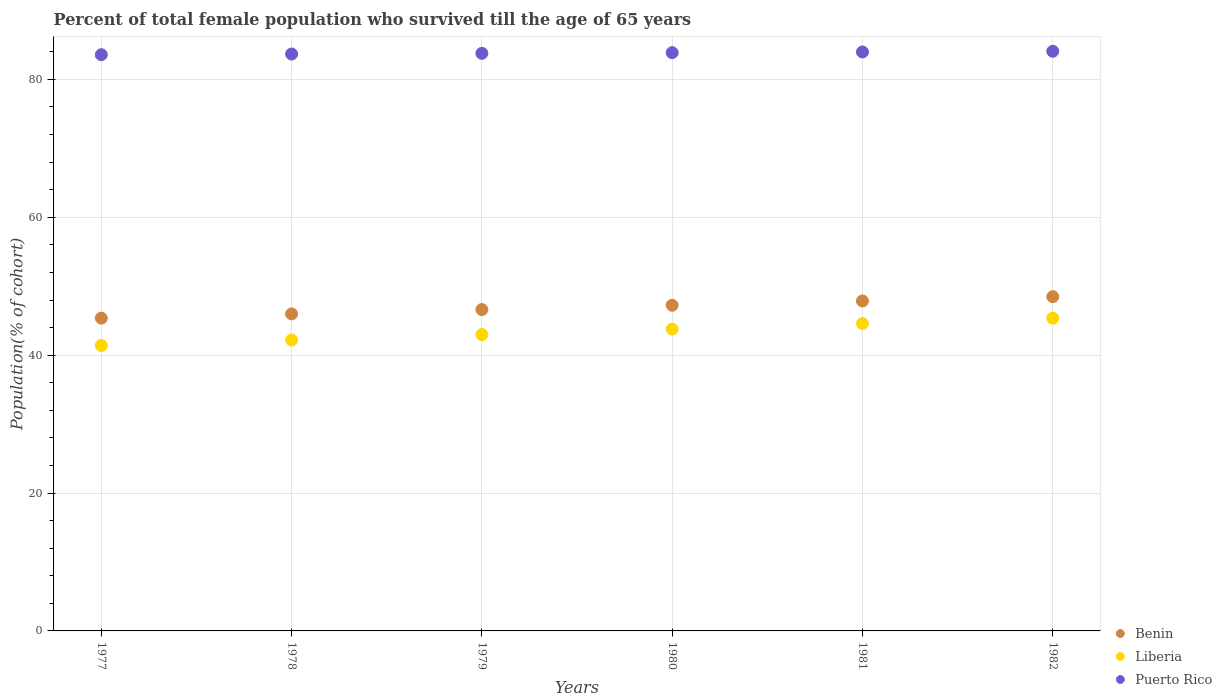Is the number of dotlines equal to the number of legend labels?
Give a very brief answer. Yes. What is the percentage of total female population who survived till the age of 65 years in Liberia in 1978?
Your answer should be very brief. 42.19. Across all years, what is the maximum percentage of total female population who survived till the age of 65 years in Benin?
Keep it short and to the point. 48.49. Across all years, what is the minimum percentage of total female population who survived till the age of 65 years in Benin?
Ensure brevity in your answer.  45.37. In which year was the percentage of total female population who survived till the age of 65 years in Puerto Rico maximum?
Offer a very short reply. 1982. In which year was the percentage of total female population who survived till the age of 65 years in Puerto Rico minimum?
Ensure brevity in your answer.  1977. What is the total percentage of total female population who survived till the age of 65 years in Liberia in the graph?
Offer a terse response. 260.31. What is the difference between the percentage of total female population who survived till the age of 65 years in Puerto Rico in 1979 and that in 1982?
Keep it short and to the point. -0.3. What is the difference between the percentage of total female population who survived till the age of 65 years in Liberia in 1978 and the percentage of total female population who survived till the age of 65 years in Puerto Rico in 1982?
Offer a very short reply. -41.88. What is the average percentage of total female population who survived till the age of 65 years in Liberia per year?
Your response must be concise. 43.38. In the year 1978, what is the difference between the percentage of total female population who survived till the age of 65 years in Benin and percentage of total female population who survived till the age of 65 years in Liberia?
Give a very brief answer. 3.8. In how many years, is the percentage of total female population who survived till the age of 65 years in Liberia greater than 80 %?
Provide a short and direct response. 0. What is the ratio of the percentage of total female population who survived till the age of 65 years in Puerto Rico in 1977 to that in 1979?
Keep it short and to the point. 1. Is the difference between the percentage of total female population who survived till the age of 65 years in Benin in 1977 and 1978 greater than the difference between the percentage of total female population who survived till the age of 65 years in Liberia in 1977 and 1978?
Offer a terse response. Yes. What is the difference between the highest and the second highest percentage of total female population who survived till the age of 65 years in Puerto Rico?
Provide a short and direct response. 0.1. What is the difference between the highest and the lowest percentage of total female population who survived till the age of 65 years in Puerto Rico?
Your answer should be compact. 0.5. In how many years, is the percentage of total female population who survived till the age of 65 years in Liberia greater than the average percentage of total female population who survived till the age of 65 years in Liberia taken over all years?
Keep it short and to the point. 3. Is the sum of the percentage of total female population who survived till the age of 65 years in Benin in 1979 and 1980 greater than the maximum percentage of total female population who survived till the age of 65 years in Puerto Rico across all years?
Your answer should be compact. Yes. Is it the case that in every year, the sum of the percentage of total female population who survived till the age of 65 years in Liberia and percentage of total female population who survived till the age of 65 years in Puerto Rico  is greater than the percentage of total female population who survived till the age of 65 years in Benin?
Ensure brevity in your answer.  Yes. Does the percentage of total female population who survived till the age of 65 years in Puerto Rico monotonically increase over the years?
Ensure brevity in your answer.  Yes. Are the values on the major ticks of Y-axis written in scientific E-notation?
Offer a very short reply. No. Does the graph contain grids?
Provide a short and direct response. Yes. Where does the legend appear in the graph?
Offer a terse response. Bottom right. How many legend labels are there?
Your answer should be very brief. 3. What is the title of the graph?
Ensure brevity in your answer.  Percent of total female population who survived till the age of 65 years. Does "European Union" appear as one of the legend labels in the graph?
Provide a succinct answer. No. What is the label or title of the X-axis?
Ensure brevity in your answer.  Years. What is the label or title of the Y-axis?
Make the answer very short. Population(% of cohort). What is the Population(% of cohort) in Benin in 1977?
Provide a short and direct response. 45.37. What is the Population(% of cohort) in Liberia in 1977?
Keep it short and to the point. 41.4. What is the Population(% of cohort) in Puerto Rico in 1977?
Make the answer very short. 83.58. What is the Population(% of cohort) in Benin in 1978?
Offer a very short reply. 45.99. What is the Population(% of cohort) in Liberia in 1978?
Your answer should be compact. 42.19. What is the Population(% of cohort) of Puerto Rico in 1978?
Ensure brevity in your answer.  83.68. What is the Population(% of cohort) of Benin in 1979?
Your answer should be very brief. 46.61. What is the Population(% of cohort) in Liberia in 1979?
Give a very brief answer. 42.99. What is the Population(% of cohort) of Puerto Rico in 1979?
Keep it short and to the point. 83.78. What is the Population(% of cohort) in Benin in 1980?
Your answer should be very brief. 47.24. What is the Population(% of cohort) of Liberia in 1980?
Your answer should be very brief. 43.78. What is the Population(% of cohort) of Puerto Rico in 1980?
Offer a terse response. 83.88. What is the Population(% of cohort) in Benin in 1981?
Your response must be concise. 47.86. What is the Population(% of cohort) of Liberia in 1981?
Your answer should be compact. 44.58. What is the Population(% of cohort) in Puerto Rico in 1981?
Keep it short and to the point. 83.98. What is the Population(% of cohort) in Benin in 1982?
Provide a short and direct response. 48.49. What is the Population(% of cohort) in Liberia in 1982?
Offer a terse response. 45.37. What is the Population(% of cohort) of Puerto Rico in 1982?
Give a very brief answer. 84.08. Across all years, what is the maximum Population(% of cohort) of Benin?
Provide a short and direct response. 48.49. Across all years, what is the maximum Population(% of cohort) of Liberia?
Provide a succinct answer. 45.37. Across all years, what is the maximum Population(% of cohort) in Puerto Rico?
Keep it short and to the point. 84.08. Across all years, what is the minimum Population(% of cohort) of Benin?
Offer a terse response. 45.37. Across all years, what is the minimum Population(% of cohort) in Liberia?
Provide a succinct answer. 41.4. Across all years, what is the minimum Population(% of cohort) of Puerto Rico?
Your answer should be very brief. 83.58. What is the total Population(% of cohort) of Benin in the graph?
Offer a very short reply. 281.56. What is the total Population(% of cohort) in Liberia in the graph?
Keep it short and to the point. 260.31. What is the total Population(% of cohort) in Puerto Rico in the graph?
Offer a terse response. 502.97. What is the difference between the Population(% of cohort) in Benin in 1977 and that in 1978?
Provide a short and direct response. -0.62. What is the difference between the Population(% of cohort) of Liberia in 1977 and that in 1978?
Offer a terse response. -0.79. What is the difference between the Population(% of cohort) of Puerto Rico in 1977 and that in 1978?
Offer a terse response. -0.1. What is the difference between the Population(% of cohort) of Benin in 1977 and that in 1979?
Offer a terse response. -1.25. What is the difference between the Population(% of cohort) in Liberia in 1977 and that in 1979?
Ensure brevity in your answer.  -1.59. What is the difference between the Population(% of cohort) of Puerto Rico in 1977 and that in 1979?
Your answer should be compact. -0.2. What is the difference between the Population(% of cohort) in Benin in 1977 and that in 1980?
Your response must be concise. -1.87. What is the difference between the Population(% of cohort) of Liberia in 1977 and that in 1980?
Your response must be concise. -2.38. What is the difference between the Population(% of cohort) in Puerto Rico in 1977 and that in 1980?
Ensure brevity in your answer.  -0.3. What is the difference between the Population(% of cohort) in Benin in 1977 and that in 1981?
Your response must be concise. -2.5. What is the difference between the Population(% of cohort) of Liberia in 1977 and that in 1981?
Make the answer very short. -3.18. What is the difference between the Population(% of cohort) of Puerto Rico in 1977 and that in 1981?
Provide a succinct answer. -0.4. What is the difference between the Population(% of cohort) in Benin in 1977 and that in 1982?
Provide a short and direct response. -3.12. What is the difference between the Population(% of cohort) of Liberia in 1977 and that in 1982?
Offer a very short reply. -3.97. What is the difference between the Population(% of cohort) of Puerto Rico in 1977 and that in 1982?
Your response must be concise. -0.5. What is the difference between the Population(% of cohort) in Benin in 1978 and that in 1979?
Offer a very short reply. -0.62. What is the difference between the Population(% of cohort) of Liberia in 1978 and that in 1979?
Offer a terse response. -0.79. What is the difference between the Population(% of cohort) in Puerto Rico in 1978 and that in 1979?
Provide a short and direct response. -0.1. What is the difference between the Population(% of cohort) of Benin in 1978 and that in 1980?
Ensure brevity in your answer.  -1.25. What is the difference between the Population(% of cohort) of Liberia in 1978 and that in 1980?
Give a very brief answer. -1.59. What is the difference between the Population(% of cohort) of Puerto Rico in 1978 and that in 1980?
Your answer should be compact. -0.2. What is the difference between the Population(% of cohort) of Benin in 1978 and that in 1981?
Your answer should be very brief. -1.87. What is the difference between the Population(% of cohort) in Liberia in 1978 and that in 1981?
Ensure brevity in your answer.  -2.38. What is the difference between the Population(% of cohort) in Puerto Rico in 1978 and that in 1981?
Provide a short and direct response. -0.3. What is the difference between the Population(% of cohort) in Benin in 1978 and that in 1982?
Keep it short and to the point. -2.5. What is the difference between the Population(% of cohort) in Liberia in 1978 and that in 1982?
Provide a short and direct response. -3.18. What is the difference between the Population(% of cohort) in Puerto Rico in 1978 and that in 1982?
Make the answer very short. -0.4. What is the difference between the Population(% of cohort) in Benin in 1979 and that in 1980?
Offer a terse response. -0.62. What is the difference between the Population(% of cohort) of Liberia in 1979 and that in 1980?
Your answer should be very brief. -0.79. What is the difference between the Population(% of cohort) in Puerto Rico in 1979 and that in 1980?
Ensure brevity in your answer.  -0.1. What is the difference between the Population(% of cohort) in Benin in 1979 and that in 1981?
Provide a short and direct response. -1.25. What is the difference between the Population(% of cohort) in Liberia in 1979 and that in 1981?
Your answer should be compact. -1.59. What is the difference between the Population(% of cohort) of Puerto Rico in 1979 and that in 1981?
Provide a short and direct response. -0.2. What is the difference between the Population(% of cohort) of Benin in 1979 and that in 1982?
Provide a short and direct response. -1.87. What is the difference between the Population(% of cohort) of Liberia in 1979 and that in 1982?
Provide a succinct answer. -2.38. What is the difference between the Population(% of cohort) in Puerto Rico in 1979 and that in 1982?
Ensure brevity in your answer.  -0.3. What is the difference between the Population(% of cohort) of Benin in 1980 and that in 1981?
Your answer should be very brief. -0.62. What is the difference between the Population(% of cohort) in Liberia in 1980 and that in 1981?
Your answer should be very brief. -0.79. What is the difference between the Population(% of cohort) in Puerto Rico in 1980 and that in 1981?
Offer a very short reply. -0.1. What is the difference between the Population(% of cohort) in Benin in 1980 and that in 1982?
Provide a succinct answer. -1.25. What is the difference between the Population(% of cohort) of Liberia in 1980 and that in 1982?
Keep it short and to the point. -1.59. What is the difference between the Population(% of cohort) in Puerto Rico in 1980 and that in 1982?
Offer a terse response. -0.2. What is the difference between the Population(% of cohort) in Benin in 1981 and that in 1982?
Provide a short and direct response. -0.62. What is the difference between the Population(% of cohort) of Liberia in 1981 and that in 1982?
Provide a short and direct response. -0.79. What is the difference between the Population(% of cohort) in Puerto Rico in 1981 and that in 1982?
Your answer should be compact. -0.1. What is the difference between the Population(% of cohort) of Benin in 1977 and the Population(% of cohort) of Liberia in 1978?
Ensure brevity in your answer.  3.17. What is the difference between the Population(% of cohort) in Benin in 1977 and the Population(% of cohort) in Puerto Rico in 1978?
Provide a succinct answer. -38.31. What is the difference between the Population(% of cohort) in Liberia in 1977 and the Population(% of cohort) in Puerto Rico in 1978?
Offer a very short reply. -42.28. What is the difference between the Population(% of cohort) in Benin in 1977 and the Population(% of cohort) in Liberia in 1979?
Ensure brevity in your answer.  2.38. What is the difference between the Population(% of cohort) of Benin in 1977 and the Population(% of cohort) of Puerto Rico in 1979?
Offer a terse response. -38.41. What is the difference between the Population(% of cohort) of Liberia in 1977 and the Population(% of cohort) of Puerto Rico in 1979?
Keep it short and to the point. -42.38. What is the difference between the Population(% of cohort) in Benin in 1977 and the Population(% of cohort) in Liberia in 1980?
Your answer should be very brief. 1.59. What is the difference between the Population(% of cohort) of Benin in 1977 and the Population(% of cohort) of Puerto Rico in 1980?
Provide a succinct answer. -38.51. What is the difference between the Population(% of cohort) of Liberia in 1977 and the Population(% of cohort) of Puerto Rico in 1980?
Keep it short and to the point. -42.48. What is the difference between the Population(% of cohort) in Benin in 1977 and the Population(% of cohort) in Liberia in 1981?
Keep it short and to the point. 0.79. What is the difference between the Population(% of cohort) in Benin in 1977 and the Population(% of cohort) in Puerto Rico in 1981?
Offer a terse response. -38.61. What is the difference between the Population(% of cohort) in Liberia in 1977 and the Population(% of cohort) in Puerto Rico in 1981?
Give a very brief answer. -42.58. What is the difference between the Population(% of cohort) of Benin in 1977 and the Population(% of cohort) of Liberia in 1982?
Your answer should be very brief. -0. What is the difference between the Population(% of cohort) of Benin in 1977 and the Population(% of cohort) of Puerto Rico in 1982?
Keep it short and to the point. -38.71. What is the difference between the Population(% of cohort) of Liberia in 1977 and the Population(% of cohort) of Puerto Rico in 1982?
Offer a terse response. -42.68. What is the difference between the Population(% of cohort) of Benin in 1978 and the Population(% of cohort) of Liberia in 1979?
Offer a terse response. 3. What is the difference between the Population(% of cohort) in Benin in 1978 and the Population(% of cohort) in Puerto Rico in 1979?
Your answer should be compact. -37.79. What is the difference between the Population(% of cohort) in Liberia in 1978 and the Population(% of cohort) in Puerto Rico in 1979?
Offer a terse response. -41.59. What is the difference between the Population(% of cohort) of Benin in 1978 and the Population(% of cohort) of Liberia in 1980?
Provide a succinct answer. 2.21. What is the difference between the Population(% of cohort) of Benin in 1978 and the Population(% of cohort) of Puerto Rico in 1980?
Give a very brief answer. -37.89. What is the difference between the Population(% of cohort) in Liberia in 1978 and the Population(% of cohort) in Puerto Rico in 1980?
Your response must be concise. -41.68. What is the difference between the Population(% of cohort) in Benin in 1978 and the Population(% of cohort) in Liberia in 1981?
Ensure brevity in your answer.  1.41. What is the difference between the Population(% of cohort) in Benin in 1978 and the Population(% of cohort) in Puerto Rico in 1981?
Make the answer very short. -37.99. What is the difference between the Population(% of cohort) of Liberia in 1978 and the Population(% of cohort) of Puerto Rico in 1981?
Make the answer very short. -41.78. What is the difference between the Population(% of cohort) in Benin in 1978 and the Population(% of cohort) in Liberia in 1982?
Ensure brevity in your answer.  0.62. What is the difference between the Population(% of cohort) in Benin in 1978 and the Population(% of cohort) in Puerto Rico in 1982?
Ensure brevity in your answer.  -38.09. What is the difference between the Population(% of cohort) in Liberia in 1978 and the Population(% of cohort) in Puerto Rico in 1982?
Offer a very short reply. -41.88. What is the difference between the Population(% of cohort) of Benin in 1979 and the Population(% of cohort) of Liberia in 1980?
Your answer should be very brief. 2.83. What is the difference between the Population(% of cohort) in Benin in 1979 and the Population(% of cohort) in Puerto Rico in 1980?
Give a very brief answer. -37.26. What is the difference between the Population(% of cohort) of Liberia in 1979 and the Population(% of cohort) of Puerto Rico in 1980?
Make the answer very short. -40.89. What is the difference between the Population(% of cohort) of Benin in 1979 and the Population(% of cohort) of Liberia in 1981?
Provide a succinct answer. 2.04. What is the difference between the Population(% of cohort) of Benin in 1979 and the Population(% of cohort) of Puerto Rico in 1981?
Offer a very short reply. -37.36. What is the difference between the Population(% of cohort) in Liberia in 1979 and the Population(% of cohort) in Puerto Rico in 1981?
Provide a short and direct response. -40.99. What is the difference between the Population(% of cohort) of Benin in 1979 and the Population(% of cohort) of Liberia in 1982?
Make the answer very short. 1.24. What is the difference between the Population(% of cohort) of Benin in 1979 and the Population(% of cohort) of Puerto Rico in 1982?
Offer a very short reply. -37.46. What is the difference between the Population(% of cohort) in Liberia in 1979 and the Population(% of cohort) in Puerto Rico in 1982?
Provide a short and direct response. -41.09. What is the difference between the Population(% of cohort) of Benin in 1980 and the Population(% of cohort) of Liberia in 1981?
Ensure brevity in your answer.  2.66. What is the difference between the Population(% of cohort) of Benin in 1980 and the Population(% of cohort) of Puerto Rico in 1981?
Your response must be concise. -36.74. What is the difference between the Population(% of cohort) of Liberia in 1980 and the Population(% of cohort) of Puerto Rico in 1981?
Provide a short and direct response. -40.2. What is the difference between the Population(% of cohort) in Benin in 1980 and the Population(% of cohort) in Liberia in 1982?
Offer a terse response. 1.87. What is the difference between the Population(% of cohort) of Benin in 1980 and the Population(% of cohort) of Puerto Rico in 1982?
Your response must be concise. -36.84. What is the difference between the Population(% of cohort) in Liberia in 1980 and the Population(% of cohort) in Puerto Rico in 1982?
Your answer should be very brief. -40.3. What is the difference between the Population(% of cohort) in Benin in 1981 and the Population(% of cohort) in Liberia in 1982?
Provide a succinct answer. 2.49. What is the difference between the Population(% of cohort) in Benin in 1981 and the Population(% of cohort) in Puerto Rico in 1982?
Provide a succinct answer. -36.21. What is the difference between the Population(% of cohort) of Liberia in 1981 and the Population(% of cohort) of Puerto Rico in 1982?
Offer a very short reply. -39.5. What is the average Population(% of cohort) of Benin per year?
Provide a short and direct response. 46.93. What is the average Population(% of cohort) in Liberia per year?
Your answer should be very brief. 43.38. What is the average Population(% of cohort) of Puerto Rico per year?
Provide a succinct answer. 83.83. In the year 1977, what is the difference between the Population(% of cohort) of Benin and Population(% of cohort) of Liberia?
Provide a short and direct response. 3.97. In the year 1977, what is the difference between the Population(% of cohort) in Benin and Population(% of cohort) in Puerto Rico?
Make the answer very short. -38.21. In the year 1977, what is the difference between the Population(% of cohort) in Liberia and Population(% of cohort) in Puerto Rico?
Offer a very short reply. -42.18. In the year 1978, what is the difference between the Population(% of cohort) of Benin and Population(% of cohort) of Liberia?
Your answer should be compact. 3.8. In the year 1978, what is the difference between the Population(% of cohort) in Benin and Population(% of cohort) in Puerto Rico?
Offer a terse response. -37.69. In the year 1978, what is the difference between the Population(% of cohort) of Liberia and Population(% of cohort) of Puerto Rico?
Your answer should be compact. -41.49. In the year 1979, what is the difference between the Population(% of cohort) of Benin and Population(% of cohort) of Liberia?
Offer a terse response. 3.63. In the year 1979, what is the difference between the Population(% of cohort) of Benin and Population(% of cohort) of Puerto Rico?
Keep it short and to the point. -37.16. In the year 1979, what is the difference between the Population(% of cohort) of Liberia and Population(% of cohort) of Puerto Rico?
Your answer should be compact. -40.79. In the year 1980, what is the difference between the Population(% of cohort) of Benin and Population(% of cohort) of Liberia?
Your answer should be very brief. 3.46. In the year 1980, what is the difference between the Population(% of cohort) in Benin and Population(% of cohort) in Puerto Rico?
Offer a terse response. -36.64. In the year 1980, what is the difference between the Population(% of cohort) in Liberia and Population(% of cohort) in Puerto Rico?
Your answer should be very brief. -40.1. In the year 1981, what is the difference between the Population(% of cohort) of Benin and Population(% of cohort) of Liberia?
Provide a short and direct response. 3.29. In the year 1981, what is the difference between the Population(% of cohort) of Benin and Population(% of cohort) of Puerto Rico?
Provide a short and direct response. -36.12. In the year 1981, what is the difference between the Population(% of cohort) of Liberia and Population(% of cohort) of Puerto Rico?
Make the answer very short. -39.4. In the year 1982, what is the difference between the Population(% of cohort) of Benin and Population(% of cohort) of Liberia?
Ensure brevity in your answer.  3.12. In the year 1982, what is the difference between the Population(% of cohort) of Benin and Population(% of cohort) of Puerto Rico?
Offer a very short reply. -35.59. In the year 1982, what is the difference between the Population(% of cohort) in Liberia and Population(% of cohort) in Puerto Rico?
Your answer should be very brief. -38.71. What is the ratio of the Population(% of cohort) of Benin in 1977 to that in 1978?
Provide a short and direct response. 0.99. What is the ratio of the Population(% of cohort) of Liberia in 1977 to that in 1978?
Make the answer very short. 0.98. What is the ratio of the Population(% of cohort) of Puerto Rico in 1977 to that in 1978?
Your response must be concise. 1. What is the ratio of the Population(% of cohort) of Benin in 1977 to that in 1979?
Keep it short and to the point. 0.97. What is the ratio of the Population(% of cohort) of Liberia in 1977 to that in 1979?
Your response must be concise. 0.96. What is the ratio of the Population(% of cohort) in Puerto Rico in 1977 to that in 1979?
Provide a succinct answer. 1. What is the ratio of the Population(% of cohort) of Benin in 1977 to that in 1980?
Offer a very short reply. 0.96. What is the ratio of the Population(% of cohort) in Liberia in 1977 to that in 1980?
Ensure brevity in your answer.  0.95. What is the ratio of the Population(% of cohort) in Benin in 1977 to that in 1981?
Your answer should be very brief. 0.95. What is the ratio of the Population(% of cohort) of Liberia in 1977 to that in 1981?
Provide a succinct answer. 0.93. What is the ratio of the Population(% of cohort) of Puerto Rico in 1977 to that in 1981?
Provide a short and direct response. 1. What is the ratio of the Population(% of cohort) in Benin in 1977 to that in 1982?
Offer a very short reply. 0.94. What is the ratio of the Population(% of cohort) of Liberia in 1977 to that in 1982?
Make the answer very short. 0.91. What is the ratio of the Population(% of cohort) of Puerto Rico in 1977 to that in 1982?
Your answer should be very brief. 0.99. What is the ratio of the Population(% of cohort) of Benin in 1978 to that in 1979?
Your response must be concise. 0.99. What is the ratio of the Population(% of cohort) in Liberia in 1978 to that in 1979?
Ensure brevity in your answer.  0.98. What is the ratio of the Population(% of cohort) of Benin in 1978 to that in 1980?
Make the answer very short. 0.97. What is the ratio of the Population(% of cohort) in Liberia in 1978 to that in 1980?
Ensure brevity in your answer.  0.96. What is the ratio of the Population(% of cohort) in Puerto Rico in 1978 to that in 1980?
Provide a short and direct response. 1. What is the ratio of the Population(% of cohort) in Benin in 1978 to that in 1981?
Make the answer very short. 0.96. What is the ratio of the Population(% of cohort) of Liberia in 1978 to that in 1981?
Provide a short and direct response. 0.95. What is the ratio of the Population(% of cohort) of Puerto Rico in 1978 to that in 1981?
Provide a short and direct response. 1. What is the ratio of the Population(% of cohort) of Benin in 1978 to that in 1982?
Keep it short and to the point. 0.95. What is the ratio of the Population(% of cohort) in Liberia in 1978 to that in 1982?
Offer a terse response. 0.93. What is the ratio of the Population(% of cohort) in Puerto Rico in 1978 to that in 1982?
Your response must be concise. 1. What is the ratio of the Population(% of cohort) in Benin in 1979 to that in 1980?
Provide a succinct answer. 0.99. What is the ratio of the Population(% of cohort) of Liberia in 1979 to that in 1980?
Ensure brevity in your answer.  0.98. What is the ratio of the Population(% of cohort) of Puerto Rico in 1979 to that in 1980?
Your answer should be very brief. 1. What is the ratio of the Population(% of cohort) of Benin in 1979 to that in 1981?
Give a very brief answer. 0.97. What is the ratio of the Population(% of cohort) of Liberia in 1979 to that in 1981?
Your answer should be compact. 0.96. What is the ratio of the Population(% of cohort) of Benin in 1979 to that in 1982?
Your response must be concise. 0.96. What is the ratio of the Population(% of cohort) in Liberia in 1979 to that in 1982?
Offer a terse response. 0.95. What is the ratio of the Population(% of cohort) in Liberia in 1980 to that in 1981?
Give a very brief answer. 0.98. What is the ratio of the Population(% of cohort) in Benin in 1980 to that in 1982?
Make the answer very short. 0.97. What is the ratio of the Population(% of cohort) of Liberia in 1980 to that in 1982?
Your response must be concise. 0.96. What is the ratio of the Population(% of cohort) in Puerto Rico in 1980 to that in 1982?
Your answer should be very brief. 1. What is the ratio of the Population(% of cohort) of Benin in 1981 to that in 1982?
Ensure brevity in your answer.  0.99. What is the ratio of the Population(% of cohort) of Liberia in 1981 to that in 1982?
Give a very brief answer. 0.98. What is the difference between the highest and the second highest Population(% of cohort) of Benin?
Your answer should be compact. 0.62. What is the difference between the highest and the second highest Population(% of cohort) in Liberia?
Keep it short and to the point. 0.79. What is the difference between the highest and the second highest Population(% of cohort) in Puerto Rico?
Your response must be concise. 0.1. What is the difference between the highest and the lowest Population(% of cohort) in Benin?
Give a very brief answer. 3.12. What is the difference between the highest and the lowest Population(% of cohort) in Liberia?
Offer a terse response. 3.97. What is the difference between the highest and the lowest Population(% of cohort) in Puerto Rico?
Keep it short and to the point. 0.5. 